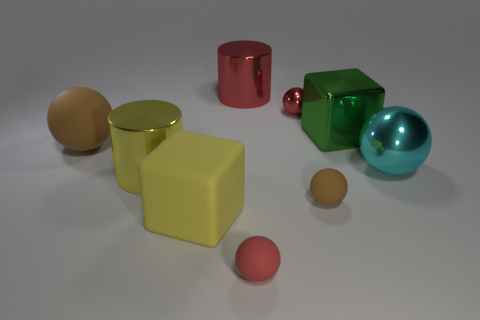Is the shape of the big yellow rubber object the same as the tiny brown rubber thing?
Your answer should be compact. No. Is there anything else that has the same material as the red cylinder?
Offer a terse response. Yes. Is the size of the red sphere that is behind the matte block the same as the metal cylinder to the left of the big yellow matte block?
Offer a very short reply. No. There is a sphere that is on the right side of the tiny red shiny sphere and to the left of the big cyan metallic object; what is it made of?
Your response must be concise. Rubber. Is there any other thing that has the same color as the big matte ball?
Ensure brevity in your answer.  Yes. Is the number of yellow metallic objects that are in front of the large yellow block less than the number of large red metal cylinders?
Ensure brevity in your answer.  Yes. Is the number of red cylinders greater than the number of big yellow metallic cubes?
Make the answer very short. Yes. There is a brown thing in front of the shiny cylinder that is to the left of the yellow matte thing; are there any yellow objects that are behind it?
Make the answer very short. Yes. What number of other things are there of the same size as the green object?
Offer a very short reply. 5. Are there any tiny matte objects behind the large cyan metal object?
Provide a short and direct response. No. 